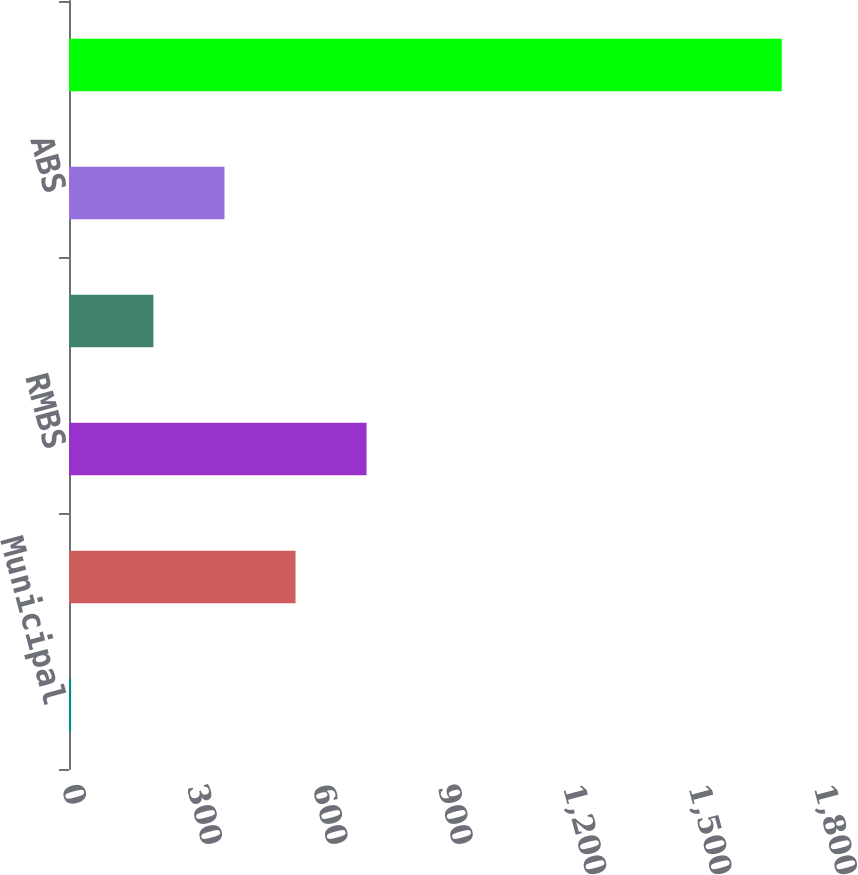Convert chart to OTSL. <chart><loc_0><loc_0><loc_500><loc_500><bar_chart><fcel>Municipal<fcel>Corporate<fcel>RMBS<fcel>CMBS<fcel>ABS<fcel>Total recurring Level 3 assets<nl><fcel>5<fcel>542.2<fcel>712.3<fcel>202<fcel>372.1<fcel>1706<nl></chart> 